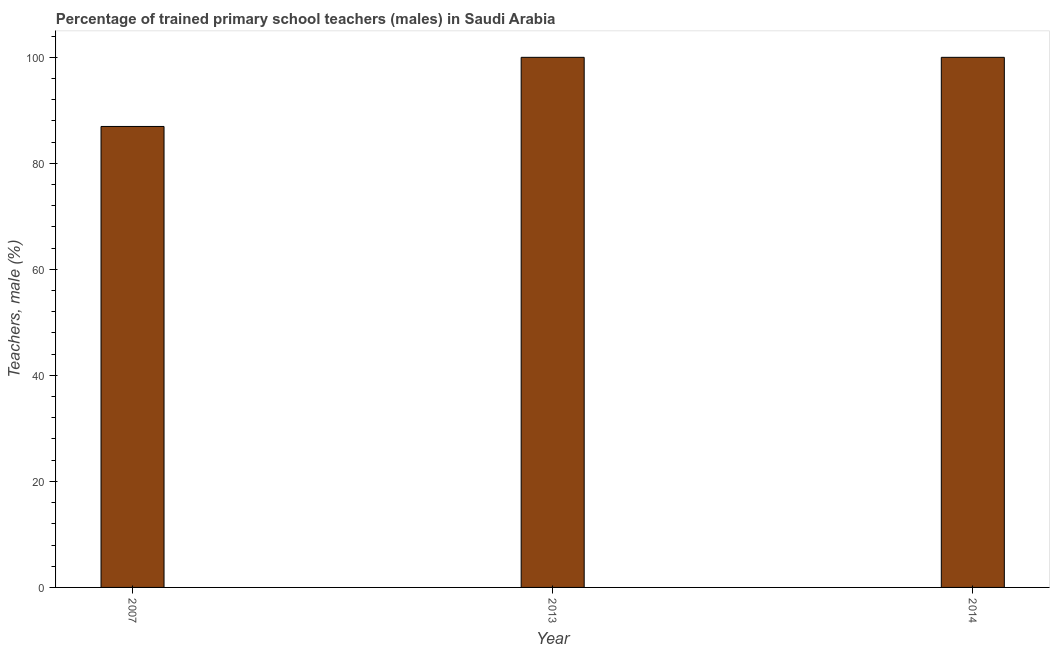Does the graph contain grids?
Ensure brevity in your answer.  No. What is the title of the graph?
Your answer should be very brief. Percentage of trained primary school teachers (males) in Saudi Arabia. What is the label or title of the Y-axis?
Your answer should be very brief. Teachers, male (%). What is the percentage of trained male teachers in 2014?
Make the answer very short. 100. Across all years, what is the minimum percentage of trained male teachers?
Offer a very short reply. 86.96. In which year was the percentage of trained male teachers minimum?
Offer a very short reply. 2007. What is the sum of the percentage of trained male teachers?
Offer a very short reply. 286.96. What is the difference between the percentage of trained male teachers in 2007 and 2013?
Offer a terse response. -13.04. What is the average percentage of trained male teachers per year?
Offer a very short reply. 95.65. In how many years, is the percentage of trained male teachers greater than 100 %?
Keep it short and to the point. 0. Is the difference between the percentage of trained male teachers in 2013 and 2014 greater than the difference between any two years?
Keep it short and to the point. No. What is the difference between the highest and the lowest percentage of trained male teachers?
Your answer should be compact. 13.04. In how many years, is the percentage of trained male teachers greater than the average percentage of trained male teachers taken over all years?
Ensure brevity in your answer.  2. Are the values on the major ticks of Y-axis written in scientific E-notation?
Offer a very short reply. No. What is the Teachers, male (%) in 2007?
Ensure brevity in your answer.  86.96. What is the Teachers, male (%) of 2014?
Keep it short and to the point. 100. What is the difference between the Teachers, male (%) in 2007 and 2013?
Make the answer very short. -13.04. What is the difference between the Teachers, male (%) in 2007 and 2014?
Give a very brief answer. -13.04. What is the difference between the Teachers, male (%) in 2013 and 2014?
Keep it short and to the point. 0. What is the ratio of the Teachers, male (%) in 2007 to that in 2013?
Give a very brief answer. 0.87. What is the ratio of the Teachers, male (%) in 2007 to that in 2014?
Provide a short and direct response. 0.87. 